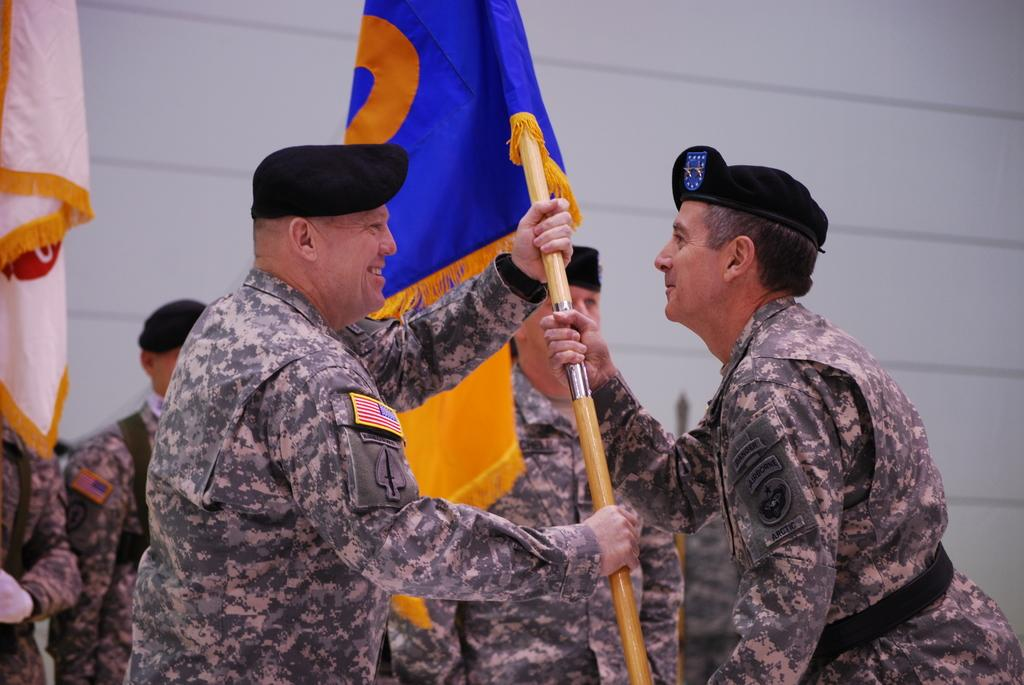How many people are in the foreground of the image? There are two persons in the foreground of the image. What are the two persons in the foreground doing? The two persons are smiling and holding a flag. Can you describe the people in the background of the image? There are people in the background of the image, but their specific actions or features are not mentioned in the provided facts. What else can be seen in the background of the image? There is a flag and a wall in the background of the image. What type of order can be seen being placed by the persons in the image? There is no indication in the image that the persons are placing an order; they are holding a flag and smiling. Can you tell me how many times the persons in the image have swum today? There is no information about swimming or any related activities in the image. 